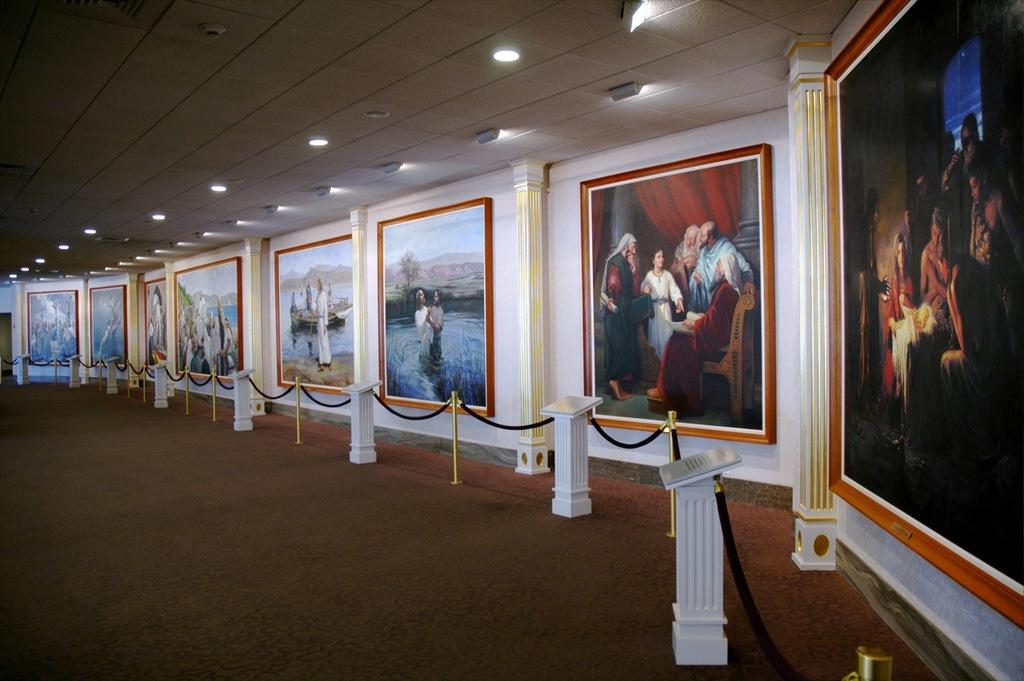What is hanging on the wall in the image? There are frames on the wall in the image. What is in front of the frames on the wall? There is a rope fence in front of the frames. What can be seen at the top of the image? There are lights visible at the top of the image. What type of clouds can be seen in the image? There are no clouds visible in the image; it features frames on the wall, a rope fence, and lights. What is the stem used for in the image? There is no stem present in the image. 